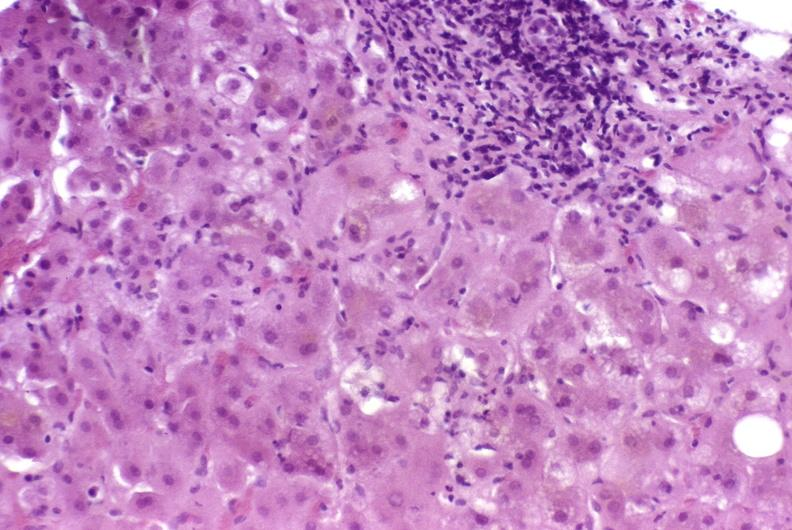what is present?
Answer the question using a single word or phrase. Hepatobiliary 